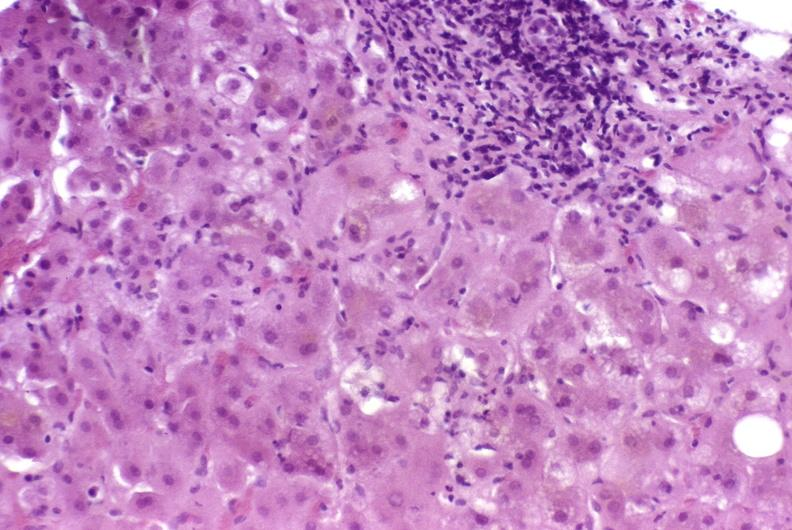what is present?
Answer the question using a single word or phrase. Hepatobiliary 